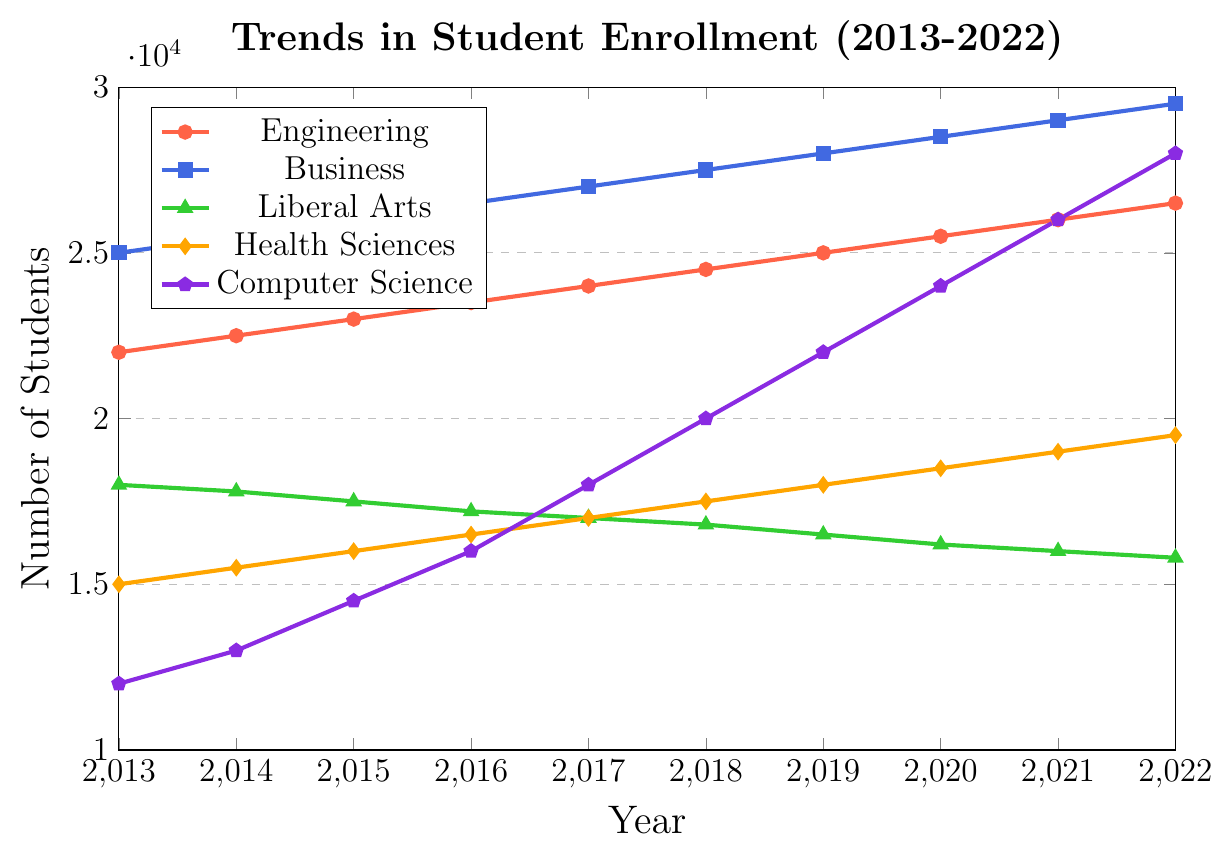Which academic discipline had the highest enrollment in 2022? The plot shows that Business had the highest enrollment. At the end of the timeline (2022), the Business line reaches 29,500 students.
Answer: Business Which academic discipline had the lowest enrollment in 2013? In 2013, the line representing Computer Science is the lowest, marking 12,000 students.
Answer: Computer Science What is the total increase in student enrollment in Health Sciences from 2013 to 2022? In 2013, Health Sciences had 15,000 students, and in 2022, it had 19,500 students. The increase is 19,500 - 15,000 = 4,500.
Answer: 4,500 Which academic discipline showed the most significant growth between 2013 and 2022? By visually comparing the lines, Computer Science showed the most significant growth, starting at 12,000 in 2013 and growing to 28,000 in 2022, an increase of 16,000 students.
Answer: Computer Science Compare the trends in enrollment for Engineering and Liberal Arts. Which discipline saw a consistent increase, and which saw a decline? Engineering saw a consistent increase from 22,000 in 2013 to 26,500 in 2022, while Liberal Arts saw a decline from 18,000 in 2013 to 15,800 in 2022.
Answer: Engineering increased, Liberal Arts declined What is the average enrollment increase per year for Business from 2013 to 2022? The enrollment for Business increased from 25,000 in 2013 to 29,500 in 2022. The total increase is 4,500 over 9 years. The average increase per year is 4,500 / 9 = 500.
Answer: 500 By how much did the enrollment in Computer Science increase in 2020 compared to 2018? In 2018, the enrollment for Computer Science was 20,000 students, and in 2020 it was 24,000 students. The increase is 24,000 - 20,000 = 4,000.
Answer: 4,000 In which year did the enrollment in Health Sciences surpass that of Liberal Arts? By comparing the lines for Health Sciences and Liberal Arts, it is clear that Health Sciences surpassed Liberal Arts in 2017.
Answer: 2017 What is the percentage increase in enrollment for Computer Science from 2013 to 2022? The enrollment in Computer Science increased from 12,000 in 2013 to 28,000 in 2022. The percentage increase is ((28,000 - 12,000) / 12,000) * 100% = 133.33%.
Answer: 133.33% What was the enrollment difference between Engineering and Business in 2015? In 2015, the enrollment for Engineering was 23,000 and for Business, it was 26,000. The difference is 26,000 - 23,000 = 3,000.
Answer: 3,000 Which year saw the highest increase in enrollment for Computer Science? The steepest part of the Computer Science line is between 2018 (20,000) and 2019 (22,000), and between 2019 (22,000) and 2020 (24,000), both with an increase of 2,000 students. Therefore, 2019 and 2020 saw the highest increase.
Answer: 2019 and 2020 